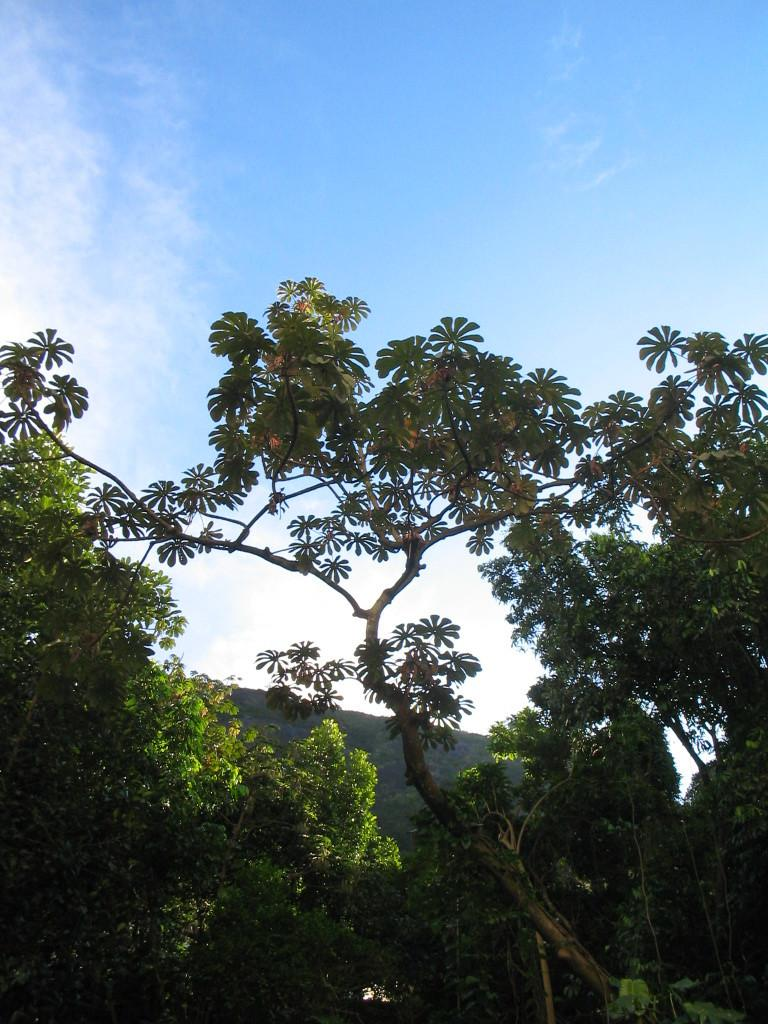What type of vegetation can be seen in the image? There are trees in the image. What natural feature is visible in the distance? There is a mountain in the backdrop of the image. What is the condition of the sky in the image? The sky is clear in the image. What type of cheese is being used to design the mountain in the image? There is no cheese present in the image; the mountain is a natural feature. How does the air affect the movement of the trees in the image? The air does not affect the movement of the trees in the image, as they are stationary. 